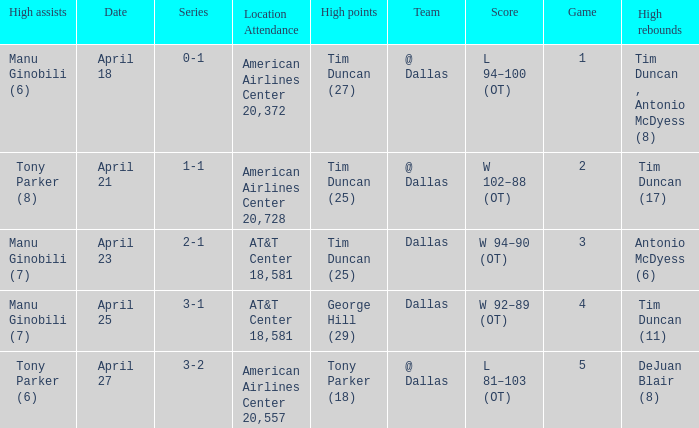When 5 is the game who has the highest amount of points? Tony Parker (18). 